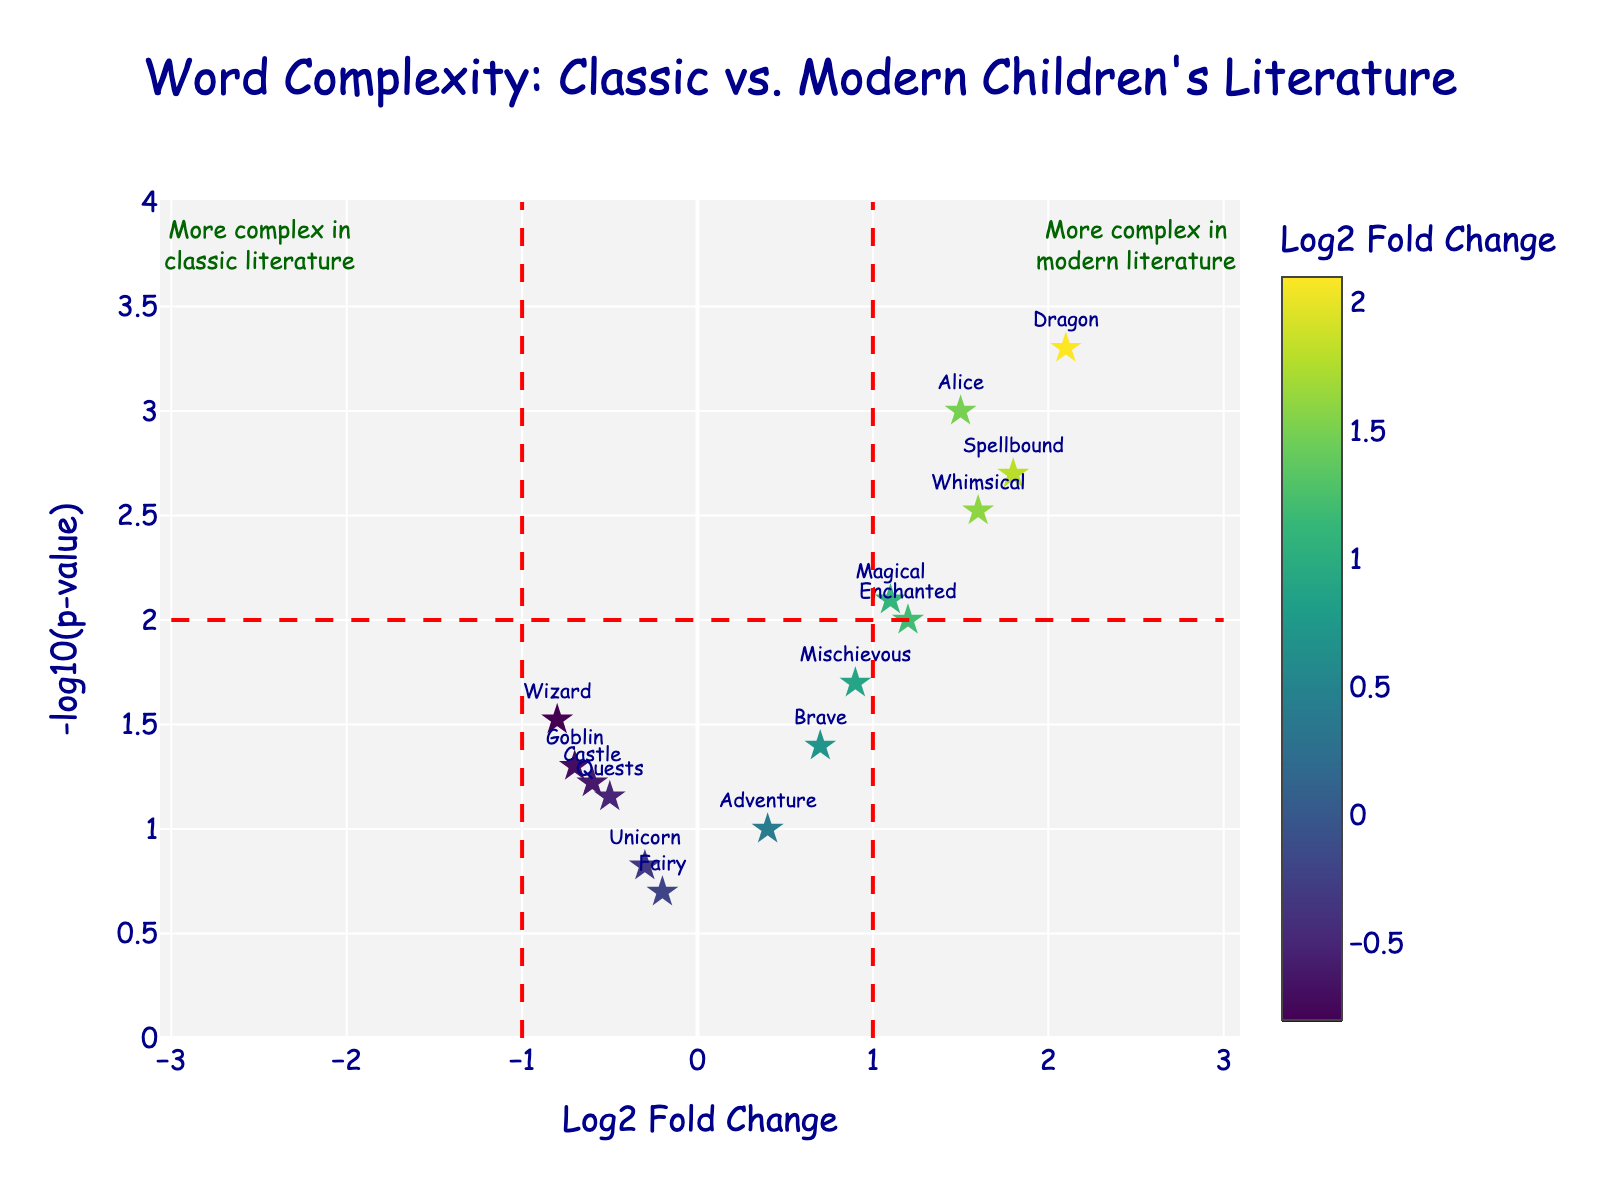What's the title of the figure? The title can be seen at the top of the figure where the text is largest.
Answer: Word Complexity: Classic vs. Modern Children's Literature What are the axes representing? The x-axis represents "Log2 Fold Change" and the y-axis represents "-log10(p-value)."
Answer: Log2 Fold Change; -log10(p-value) Which word has the highest -log10(p-value)? Looking at the y-values, "Dragon" is the highest on the plot.
Answer: Dragon Which words are more complex in modern literature compared to classic literature? Words with positive Log2 Fold Change values are more complex in modern literature. These words include "Alice," "Dragon," "Enchanted," "Spellbound," "Whimsical," "Mischievous," "Magical," and "Brave."
Answer: Alice, Dragon, Enchanted, Spellbound, Whimsical, Mischievous, Magical, Brave How many words have a p-value less than 0.01? A p-value less than 0.01 corresponds to a -log10(p-value) greater than 2. These words are "Dragon," "Alice," and "Spellbound."
Answer: 3 Is "Goblin" more common in classic or modern literature? "Goblin" has a negative Log2 Fold Change value, which indicates it is more common in classic literature.
Answer: Classic literature Which word is closest to the threshold line for modern literature complexity? The threshold line for modern literature is at Log2 Fold Change = 1. "Magical" is closest to this line with a Log2 Fold Change of 1.1.
Answer: Magical What does the color bar represent in the figure? The color bar shows the range of Log2 Fold Change values, indicating how much more complex the words are in either classic or modern literature.
Answer: Log2 Fold Change Are there more words with positive or negative Log2 Fold Change values? Answer by counting the number of words on each side of the vertical line at Log2 Fold Change = 0. Counting the words on each side, there are more words with positive Log2 Fold Change values; 8 positive and 7 negative.
Answer: Positive, 8 Which word has the lowest -log10(p-value) value? "Fairy" has the lowest y-value on the plot.
Answer: Fairy 